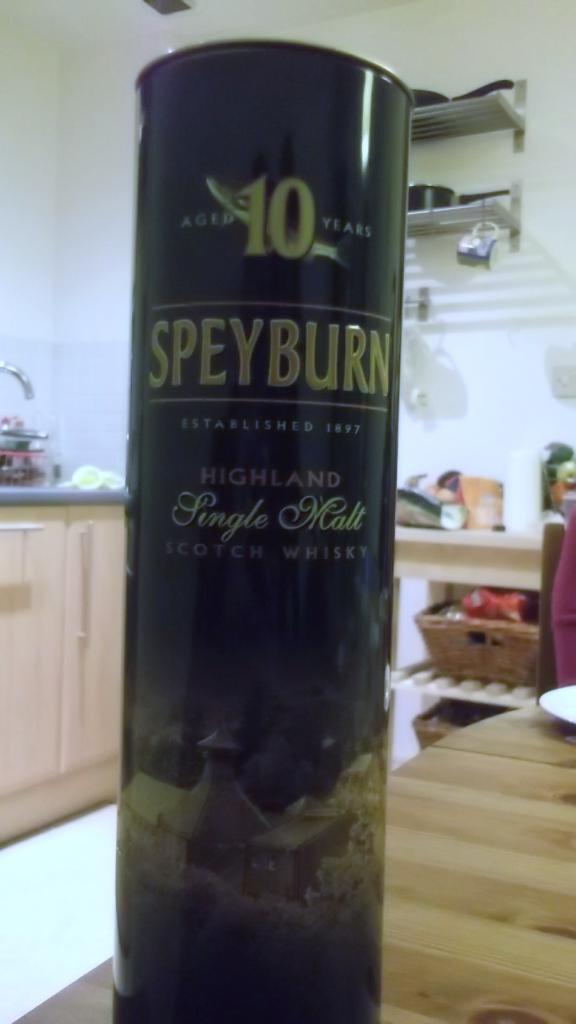How long was this whiskey aged?
Offer a terse response. 10 years. What kind is it?
Your answer should be very brief. Speyburn. 